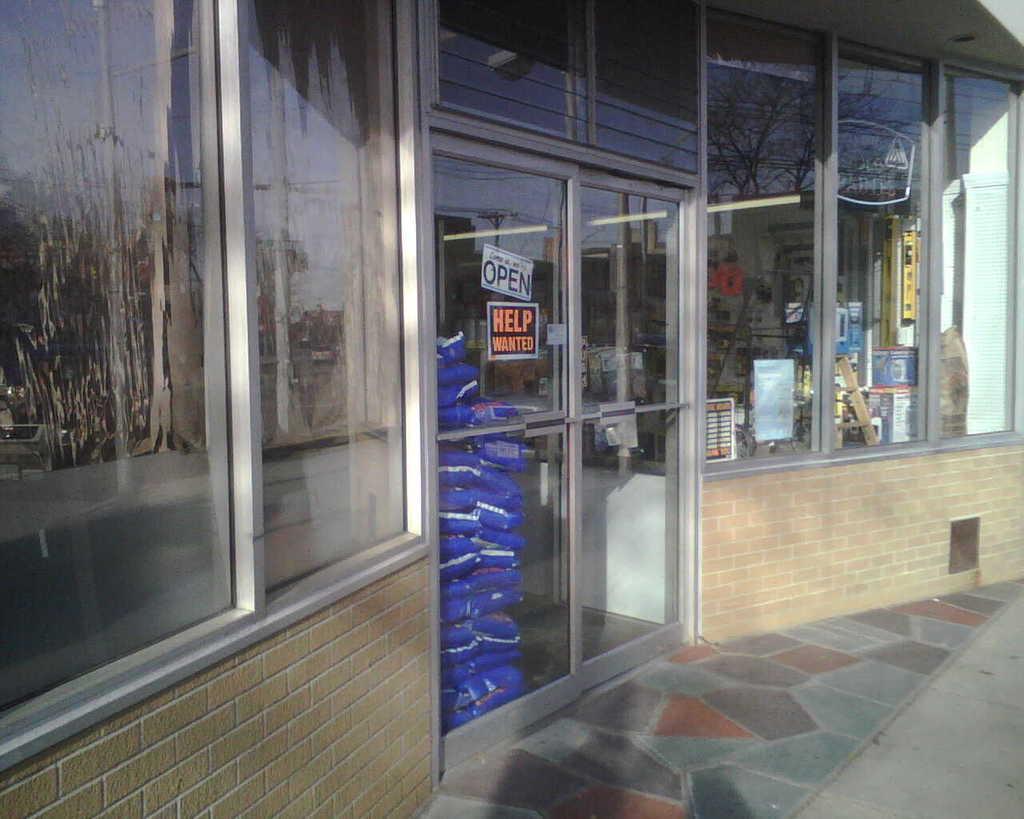What is wanted in this store?
Make the answer very short. Help. Does this place need help?
Offer a terse response. Yes. 